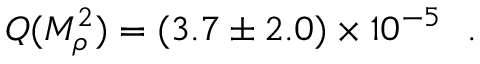Convert formula to latex. <formula><loc_0><loc_0><loc_500><loc_500>Q ( M _ { \rho } ^ { 2 } ) = ( 3 . 7 \pm 2 . 0 ) \times 1 0 ^ { - 5 } \ \ .</formula> 